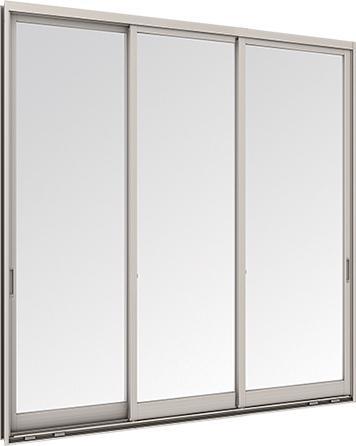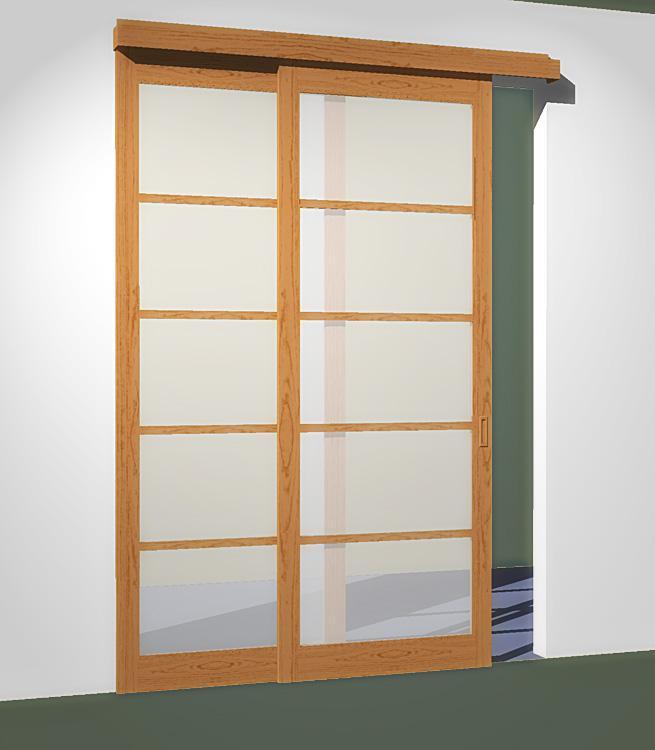The first image is the image on the left, the second image is the image on the right. Examine the images to the left and right. Is the description "The door in one of the images is ajar." accurate? Answer yes or no. Yes. The first image is the image on the left, the second image is the image on the right. For the images displayed, is the sentence "An image shows a silver-framed sliding door unit with three plain glass panels." factually correct? Answer yes or no. Yes. 